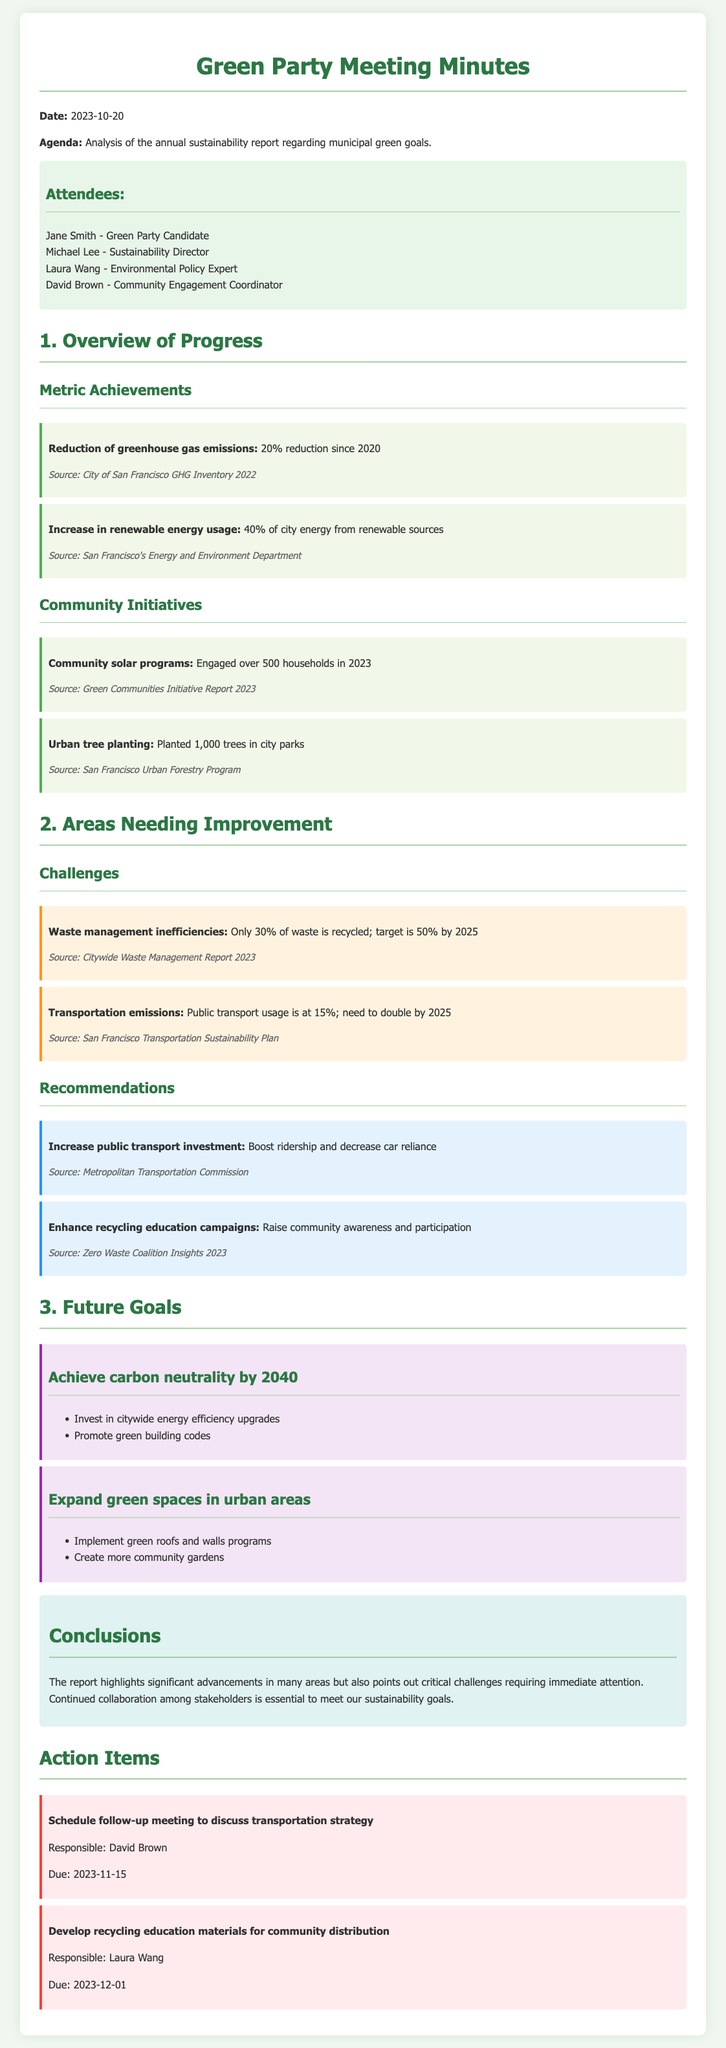what is the date of the meeting? The date of the meeting is explicitly mentioned in the document as 2023-10-20.
Answer: 2023-10-20 who is the Sustainability Director? The document lists the attendees, identifying Michael Lee as the Sustainability Director.
Answer: Michael Lee what percentage reduction in greenhouse gas emissions has been achieved since 2020? The document states a 20% reduction in greenhouse gas emissions since 2020.
Answer: 20% how many trees were planted in city parks? According to the report, 1,000 trees were planted in city parks.
Answer: 1,000 trees what percentage of waste is currently recycled? The meeting minutes indicate that only 30% of waste is recycled.
Answer: 30% what is the target recycling percentage by 2025? The document specifies that the target for recycling waste is 50% by 2025.
Answer: 50% what is a future goal regarding carbon neutrality? The document mentions a goal to achieve carbon neutrality by 2040.
Answer: Achieve carbon neutrality by 2040 name one community initiative mentioned in the report. The report highlights community solar programs as one initiative.
Answer: Community solar programs who is responsible for developing recycling education materials? The action item states that Laura Wang is responsible for developing recycling education materials.
Answer: Laura Wang 